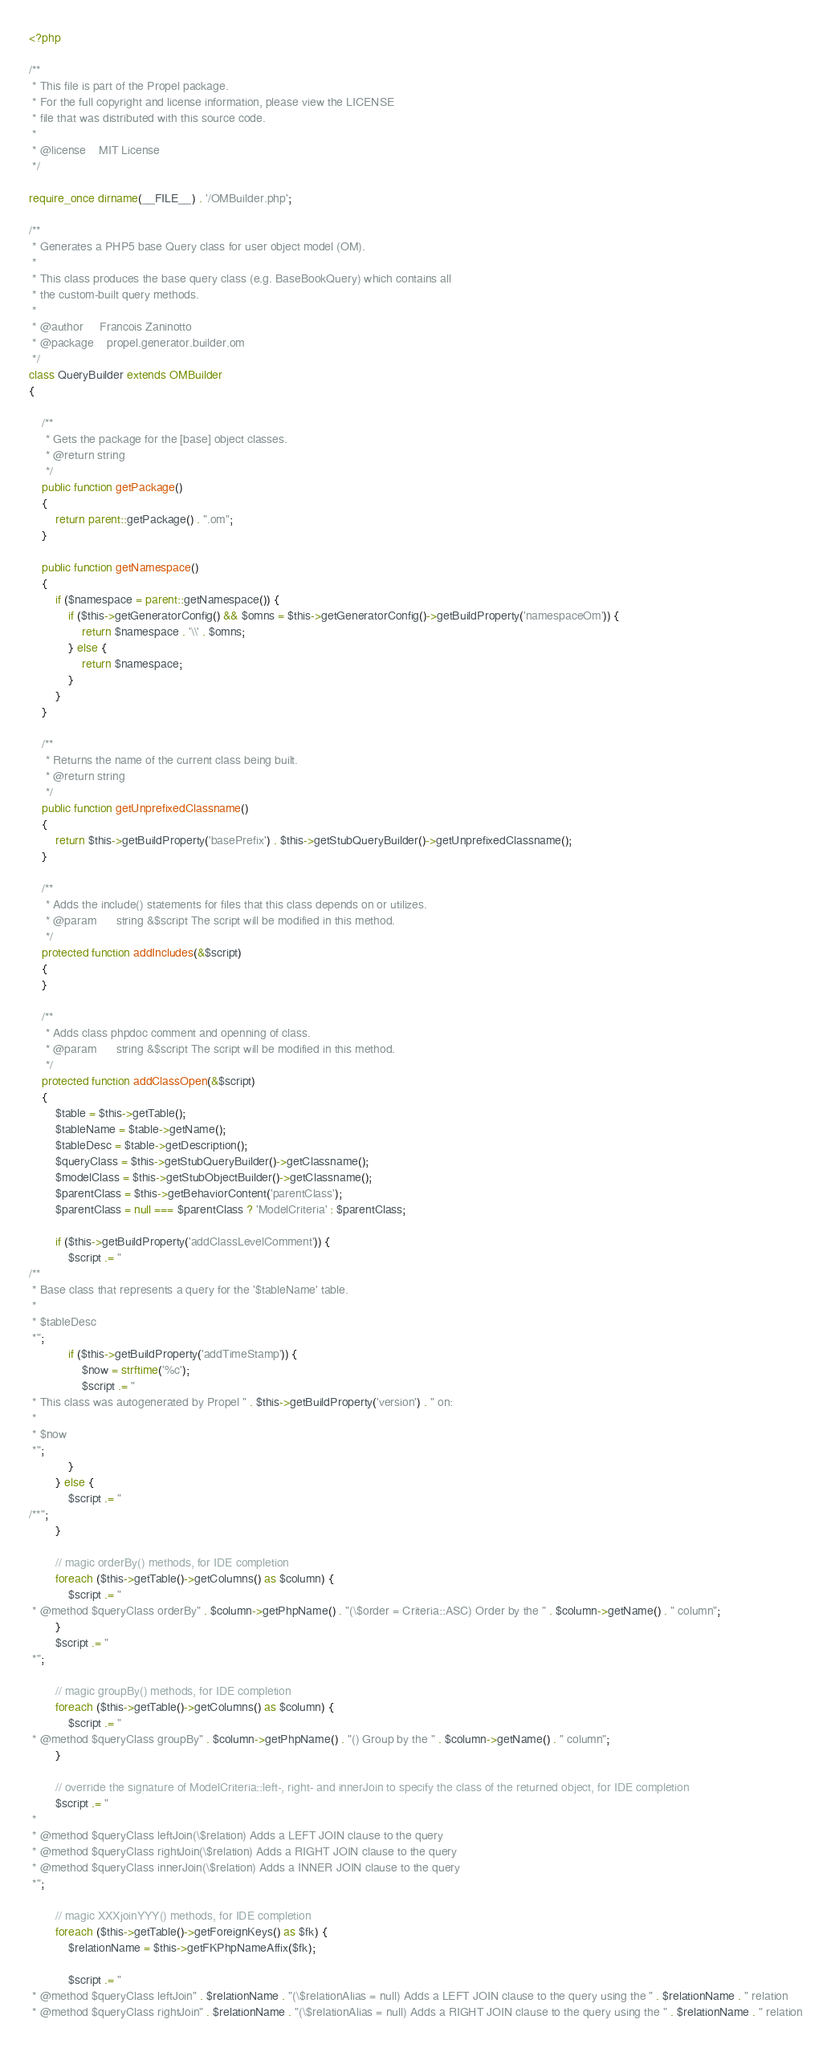Convert code to text. <code><loc_0><loc_0><loc_500><loc_500><_PHP_><?php

/**
 * This file is part of the Propel package.
 * For the full copyright and license information, please view the LICENSE
 * file that was distributed with this source code.
 *
 * @license    MIT License
 */

require_once dirname(__FILE__) . '/OMBuilder.php';

/**
 * Generates a PHP5 base Query class for user object model (OM).
 *
 * This class produces the base query class (e.g. BaseBookQuery) which contains all
 * the custom-built query methods.
 *
 * @author     Francois Zaninotto
 * @package    propel.generator.builder.om
 */
class QueryBuilder extends OMBuilder
{

    /**
     * Gets the package for the [base] object classes.
     * @return string
     */
    public function getPackage()
    {
        return parent::getPackage() . ".om";
    }

    public function getNamespace()
    {
        if ($namespace = parent::getNamespace()) {
            if ($this->getGeneratorConfig() && $omns = $this->getGeneratorConfig()->getBuildProperty('namespaceOm')) {
                return $namespace . '\\' . $omns;
            } else {
                return $namespace;
            }
        }
    }

    /**
     * Returns the name of the current class being built.
     * @return string
     */
    public function getUnprefixedClassname()
    {
        return $this->getBuildProperty('basePrefix') . $this->getStubQueryBuilder()->getUnprefixedClassname();
    }

    /**
     * Adds the include() statements for files that this class depends on or utilizes.
     * @param      string &$script The script will be modified in this method.
     */
    protected function addIncludes(&$script)
    {
    }

    /**
     * Adds class phpdoc comment and openning of class.
     * @param      string &$script The script will be modified in this method.
     */
    protected function addClassOpen(&$script)
    {
        $table = $this->getTable();
        $tableName = $table->getName();
        $tableDesc = $table->getDescription();
        $queryClass = $this->getStubQueryBuilder()->getClassname();
        $modelClass = $this->getStubObjectBuilder()->getClassname();
        $parentClass = $this->getBehaviorContent('parentClass');
        $parentClass = null === $parentClass ? 'ModelCriteria' : $parentClass;

        if ($this->getBuildProperty('addClassLevelComment')) {
            $script .= "
/**
 * Base class that represents a query for the '$tableName' table.
 *
 * $tableDesc
 *";
            if ($this->getBuildProperty('addTimeStamp')) {
                $now = strftime('%c');
                $script .= "
 * This class was autogenerated by Propel " . $this->getBuildProperty('version') . " on:
 *
 * $now
 *";
            }
        } else {
            $script .= "
/**";
        }

        // magic orderBy() methods, for IDE completion
        foreach ($this->getTable()->getColumns() as $column) {
            $script .= "
 * @method $queryClass orderBy" . $column->getPhpName() . "(\$order = Criteria::ASC) Order by the " . $column->getName() . " column";
        }
        $script .= "
 *";

        // magic groupBy() methods, for IDE completion
        foreach ($this->getTable()->getColumns() as $column) {
            $script .= "
 * @method $queryClass groupBy" . $column->getPhpName() . "() Group by the " . $column->getName() . " column";
        }

        // override the signature of ModelCriteria::left-, right- and innerJoin to specify the class of the returned object, for IDE completion
        $script .= "
 *
 * @method $queryClass leftJoin(\$relation) Adds a LEFT JOIN clause to the query
 * @method $queryClass rightJoin(\$relation) Adds a RIGHT JOIN clause to the query
 * @method $queryClass innerJoin(\$relation) Adds a INNER JOIN clause to the query
 *";

        // magic XXXjoinYYY() methods, for IDE completion
        foreach ($this->getTable()->getForeignKeys() as $fk) {
            $relationName = $this->getFKPhpNameAffix($fk);

            $script .= "
 * @method $queryClass leftJoin" . $relationName . "(\$relationAlias = null) Adds a LEFT JOIN clause to the query using the " . $relationName . " relation
 * @method $queryClass rightJoin" . $relationName . "(\$relationAlias = null) Adds a RIGHT JOIN clause to the query using the " . $relationName . " relation</code> 